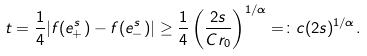<formula> <loc_0><loc_0><loc_500><loc_500>t = \frac { 1 } { 4 } | f ( e _ { + } ^ { s } ) - f ( e _ { - } ^ { s } ) | \geq \frac { 1 } { 4 } \left ( \frac { 2 s } { C r _ { 0 } } \right ) ^ { 1 / \alpha } = \colon c ( 2 s ) ^ { 1 / \alpha } .</formula> 